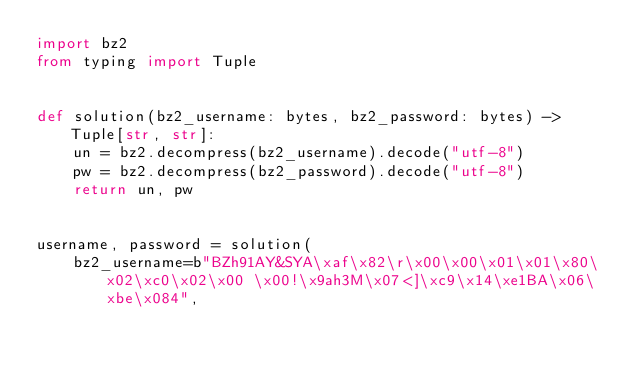<code> <loc_0><loc_0><loc_500><loc_500><_Python_>import bz2
from typing import Tuple


def solution(bz2_username: bytes, bz2_password: bytes) -> Tuple[str, str]:
    un = bz2.decompress(bz2_username).decode("utf-8")
    pw = bz2.decompress(bz2_password).decode("utf-8")
    return un, pw


username, password = solution(
    bz2_username=b"BZh91AY&SYA\xaf\x82\r\x00\x00\x01\x01\x80\x02\xc0\x02\x00 \x00!\x9ah3M\x07<]\xc9\x14\xe1BA\x06\xbe\x084",</code> 